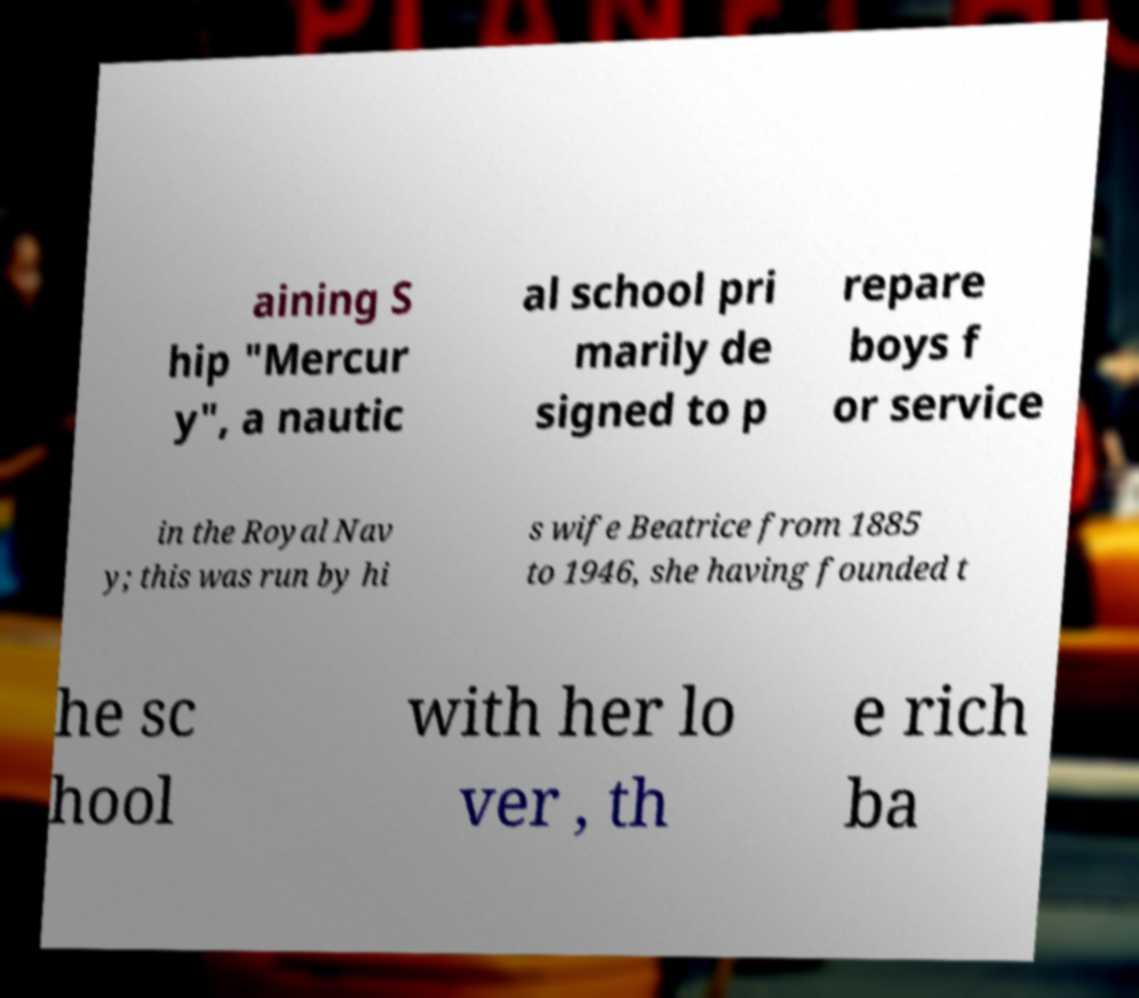I need the written content from this picture converted into text. Can you do that? aining S hip "Mercur y", a nautic al school pri marily de signed to p repare boys f or service in the Royal Nav y; this was run by hi s wife Beatrice from 1885 to 1946, she having founded t he sc hool with her lo ver , th e rich ba 